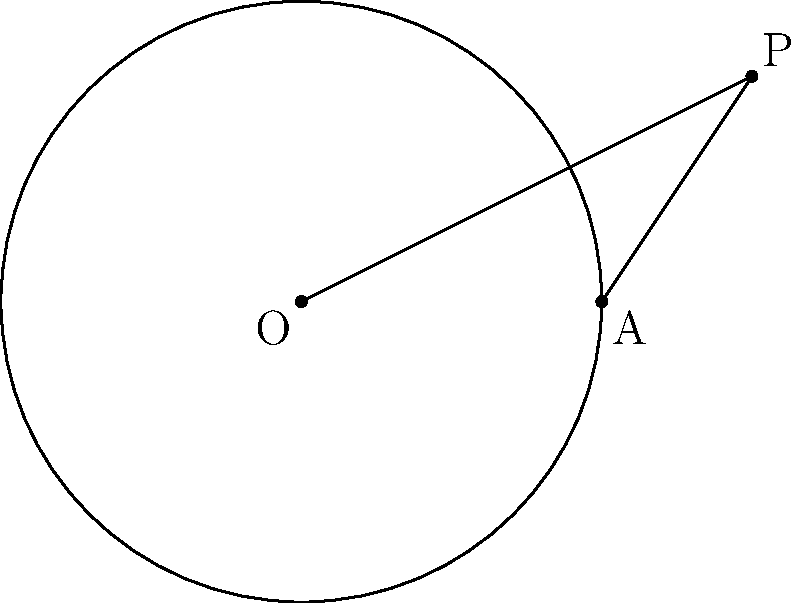In the diagram, O is the center of the circle with radius 4 units. Point P is outside the circle, and PA is a tangent to the circle at point A. If OP = $\sqrt{13}$ units, calculate the length of the tangent PA. Let's approach this step-by-step:

1) In a circle, a tangent line is perpendicular to the radius drawn to the point of tangency. Therefore, OAP is a right-angled triangle with the right angle at A.

2) We can use the Pythagorean theorem in this right-angled triangle:

   $OP^2 = OA^2 + PA^2$

3) We know that:
   - OP = $\sqrt{13}$
   - OA is the radius of the circle, which is 4

4) Let's substitute these values into the Pythagorean theorem:
   
   $(\sqrt{13})^2 = 4^2 + PA^2$

5) Simplify:
   
   $13 = 16 + PA^2$

6) Subtract 16 from both sides:
   
   $-3 = PA^2$

7) Take the square root of both sides:
   
   $PA = \sqrt{3}$

Therefore, the length of the tangent PA is $\sqrt{3}$ units.
Answer: $\sqrt{3}$ units 